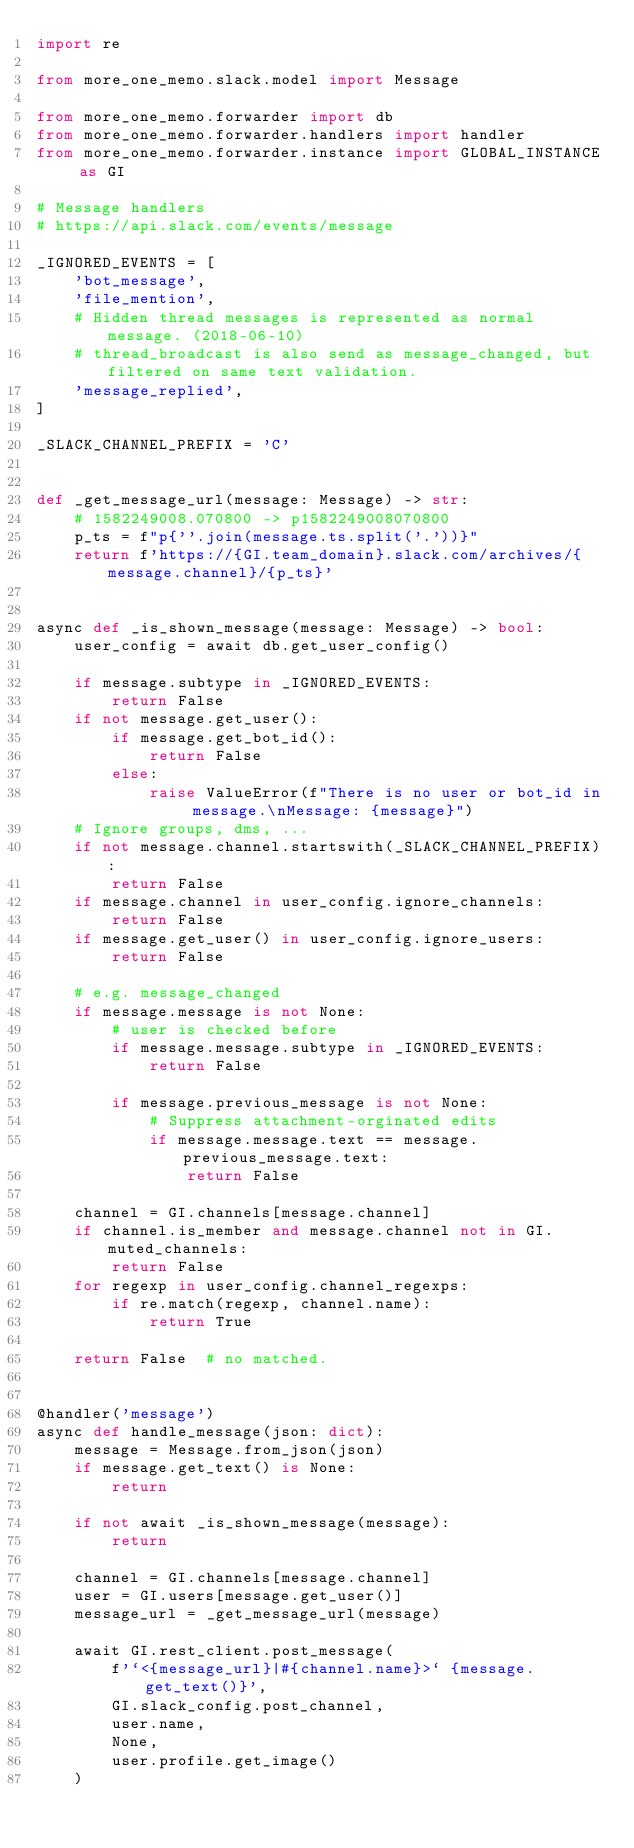<code> <loc_0><loc_0><loc_500><loc_500><_Python_>import re

from more_one_memo.slack.model import Message

from more_one_memo.forwarder import db
from more_one_memo.forwarder.handlers import handler
from more_one_memo.forwarder.instance import GLOBAL_INSTANCE as GI

# Message handlers
# https://api.slack.com/events/message

_IGNORED_EVENTS = [
    'bot_message',
    'file_mention',
    # Hidden thread messages is represented as normal message. (2018-06-10)
    # thread_broadcast is also send as message_changed, but filtered on same text validation.
    'message_replied',
]

_SLACK_CHANNEL_PREFIX = 'C'


def _get_message_url(message: Message) -> str:
    # 1582249008.070800 -> p1582249008070800
    p_ts = f"p{''.join(message.ts.split('.'))}"
    return f'https://{GI.team_domain}.slack.com/archives/{message.channel}/{p_ts}'


async def _is_shown_message(message: Message) -> bool:
    user_config = await db.get_user_config()

    if message.subtype in _IGNORED_EVENTS:
        return False
    if not message.get_user():
        if message.get_bot_id():
            return False
        else:
            raise ValueError(f"There is no user or bot_id in message.\nMessage: {message}")
    # Ignore groups, dms, ...
    if not message.channel.startswith(_SLACK_CHANNEL_PREFIX):
        return False
    if message.channel in user_config.ignore_channels:
        return False
    if message.get_user() in user_config.ignore_users:
        return False

    # e.g. message_changed
    if message.message is not None:
        # user is checked before
        if message.message.subtype in _IGNORED_EVENTS:
            return False

        if message.previous_message is not None:
            # Suppress attachment-orginated edits
            if message.message.text == message.previous_message.text:
                return False

    channel = GI.channels[message.channel]
    if channel.is_member and message.channel not in GI.muted_channels:
        return False
    for regexp in user_config.channel_regexps:
        if re.match(regexp, channel.name):
            return True

    return False  # no matched.


@handler('message')
async def handle_message(json: dict):
    message = Message.from_json(json)
    if message.get_text() is None:
        return

    if not await _is_shown_message(message):
        return

    channel = GI.channels[message.channel]
    user = GI.users[message.get_user()]
    message_url = _get_message_url(message)

    await GI.rest_client.post_message(
        f'`<{message_url}|#{channel.name}>` {message.get_text()}',
        GI.slack_config.post_channel,
        user.name,
        None,
        user.profile.get_image()
    )
</code> 